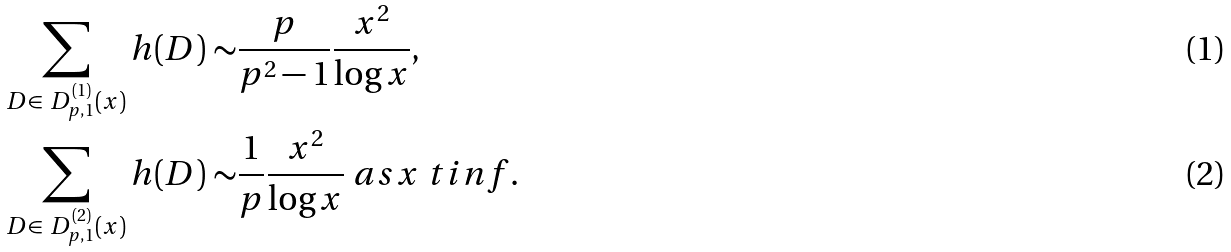<formula> <loc_0><loc_0><loc_500><loc_500>\sum _ { D \in \ D _ { p , 1 } ^ { ( 1 ) } ( x ) } h ( D ) \sim & \frac { p } { p ^ { 2 } - 1 } \frac { x ^ { 2 } } { \log { x } } , \\ \sum _ { D \in \ D _ { p , 1 } ^ { ( 2 ) } ( x ) } h ( D ) \sim & \frac { 1 } { p } \frac { x ^ { 2 } } { \log { x } } \ a s x \ t i n f .</formula> 